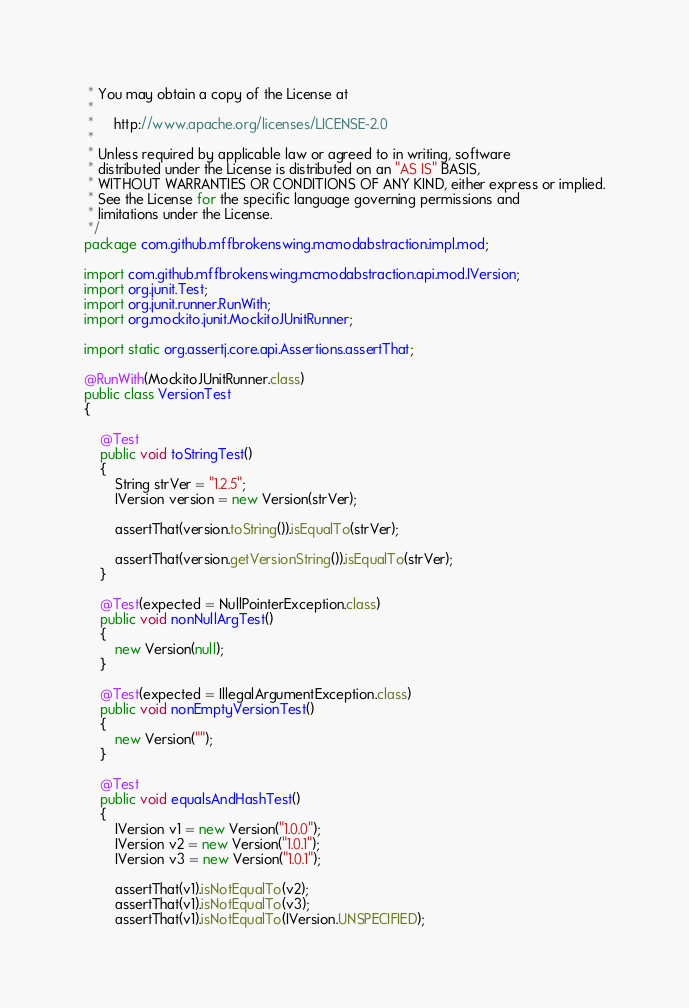<code> <loc_0><loc_0><loc_500><loc_500><_Java_> * You may obtain a copy of the License at
 *
 *     http://www.apache.org/licenses/LICENSE-2.0
 *
 * Unless required by applicable law or agreed to in writing, software
 * distributed under the License is distributed on an "AS IS" BASIS,
 * WITHOUT WARRANTIES OR CONDITIONS OF ANY KIND, either express or implied.
 * See the License for the specific language governing permissions and
 * limitations under the License.
 */
package com.github.mffbrokenswing.mcmodabstraction.impl.mod;

import com.github.mffbrokenswing.mcmodabstraction.api.mod.IVersion;
import org.junit.Test;
import org.junit.runner.RunWith;
import org.mockito.junit.MockitoJUnitRunner;

import static org.assertj.core.api.Assertions.assertThat;

@RunWith(MockitoJUnitRunner.class)
public class VersionTest
{

    @Test
    public void toStringTest()
    {
        String strVer = "1.2.5";
        IVersion version = new Version(strVer);

        assertThat(version.toString()).isEqualTo(strVer);

        assertThat(version.getVersionString()).isEqualTo(strVer);
    }

    @Test(expected = NullPointerException.class)
    public void nonNullArgTest()
    {
        new Version(null);
    }

    @Test(expected = IllegalArgumentException.class)
    public void nonEmptyVersionTest()
    {
        new Version("");
    }

    @Test
    public void equalsAndHashTest()
    {
        IVersion v1 = new Version("1.0.0");
        IVersion v2 = new Version("1.0.1");
        IVersion v3 = new Version("1.0.1");

        assertThat(v1).isNotEqualTo(v2);
        assertThat(v1).isNotEqualTo(v3);
        assertThat(v1).isNotEqualTo(IVersion.UNSPECIFIED);
</code> 